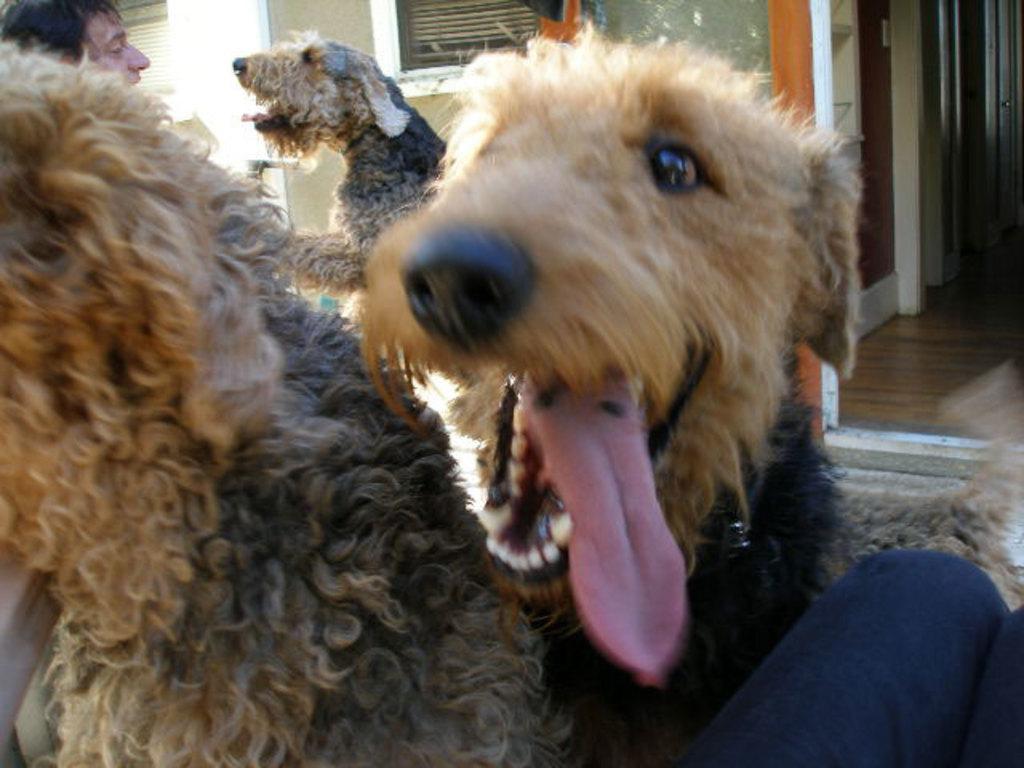How would you summarize this image in a sentence or two? This image consists of dogs. On the left, we can see a man. In the background, there is a building along with windows and doors. The dogs are in brown color. 